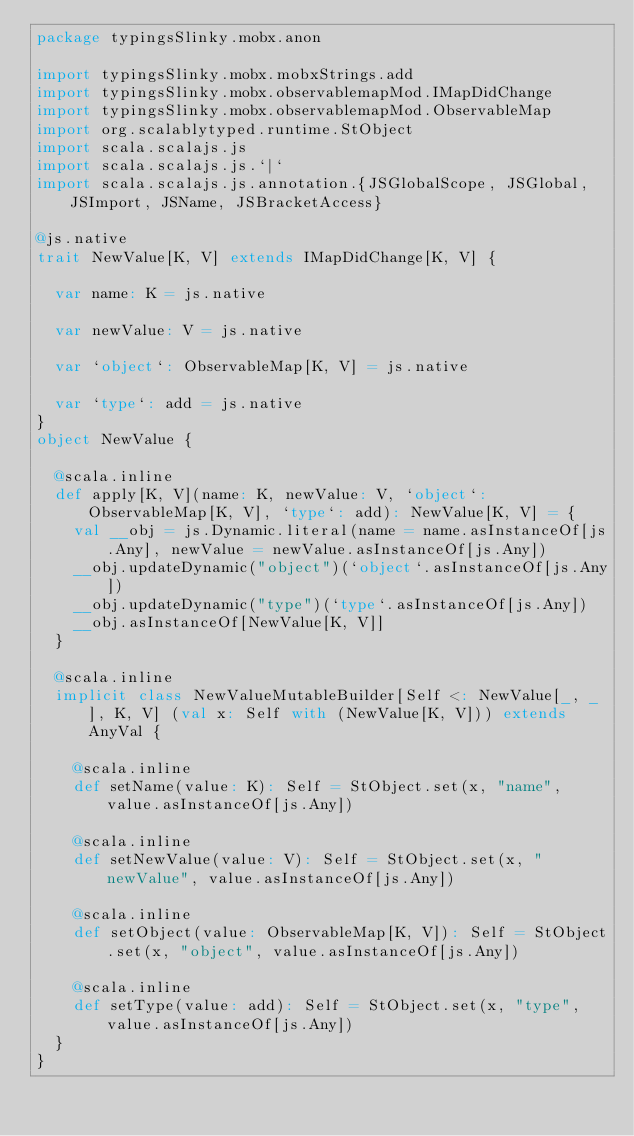<code> <loc_0><loc_0><loc_500><loc_500><_Scala_>package typingsSlinky.mobx.anon

import typingsSlinky.mobx.mobxStrings.add
import typingsSlinky.mobx.observablemapMod.IMapDidChange
import typingsSlinky.mobx.observablemapMod.ObservableMap
import org.scalablytyped.runtime.StObject
import scala.scalajs.js
import scala.scalajs.js.`|`
import scala.scalajs.js.annotation.{JSGlobalScope, JSGlobal, JSImport, JSName, JSBracketAccess}

@js.native
trait NewValue[K, V] extends IMapDidChange[K, V] {
  
  var name: K = js.native
  
  var newValue: V = js.native
  
  var `object`: ObservableMap[K, V] = js.native
  
  var `type`: add = js.native
}
object NewValue {
  
  @scala.inline
  def apply[K, V](name: K, newValue: V, `object`: ObservableMap[K, V], `type`: add): NewValue[K, V] = {
    val __obj = js.Dynamic.literal(name = name.asInstanceOf[js.Any], newValue = newValue.asInstanceOf[js.Any])
    __obj.updateDynamic("object")(`object`.asInstanceOf[js.Any])
    __obj.updateDynamic("type")(`type`.asInstanceOf[js.Any])
    __obj.asInstanceOf[NewValue[K, V]]
  }
  
  @scala.inline
  implicit class NewValueMutableBuilder[Self <: NewValue[_, _], K, V] (val x: Self with (NewValue[K, V])) extends AnyVal {
    
    @scala.inline
    def setName(value: K): Self = StObject.set(x, "name", value.asInstanceOf[js.Any])
    
    @scala.inline
    def setNewValue(value: V): Self = StObject.set(x, "newValue", value.asInstanceOf[js.Any])
    
    @scala.inline
    def setObject(value: ObservableMap[K, V]): Self = StObject.set(x, "object", value.asInstanceOf[js.Any])
    
    @scala.inline
    def setType(value: add): Self = StObject.set(x, "type", value.asInstanceOf[js.Any])
  }
}
</code> 